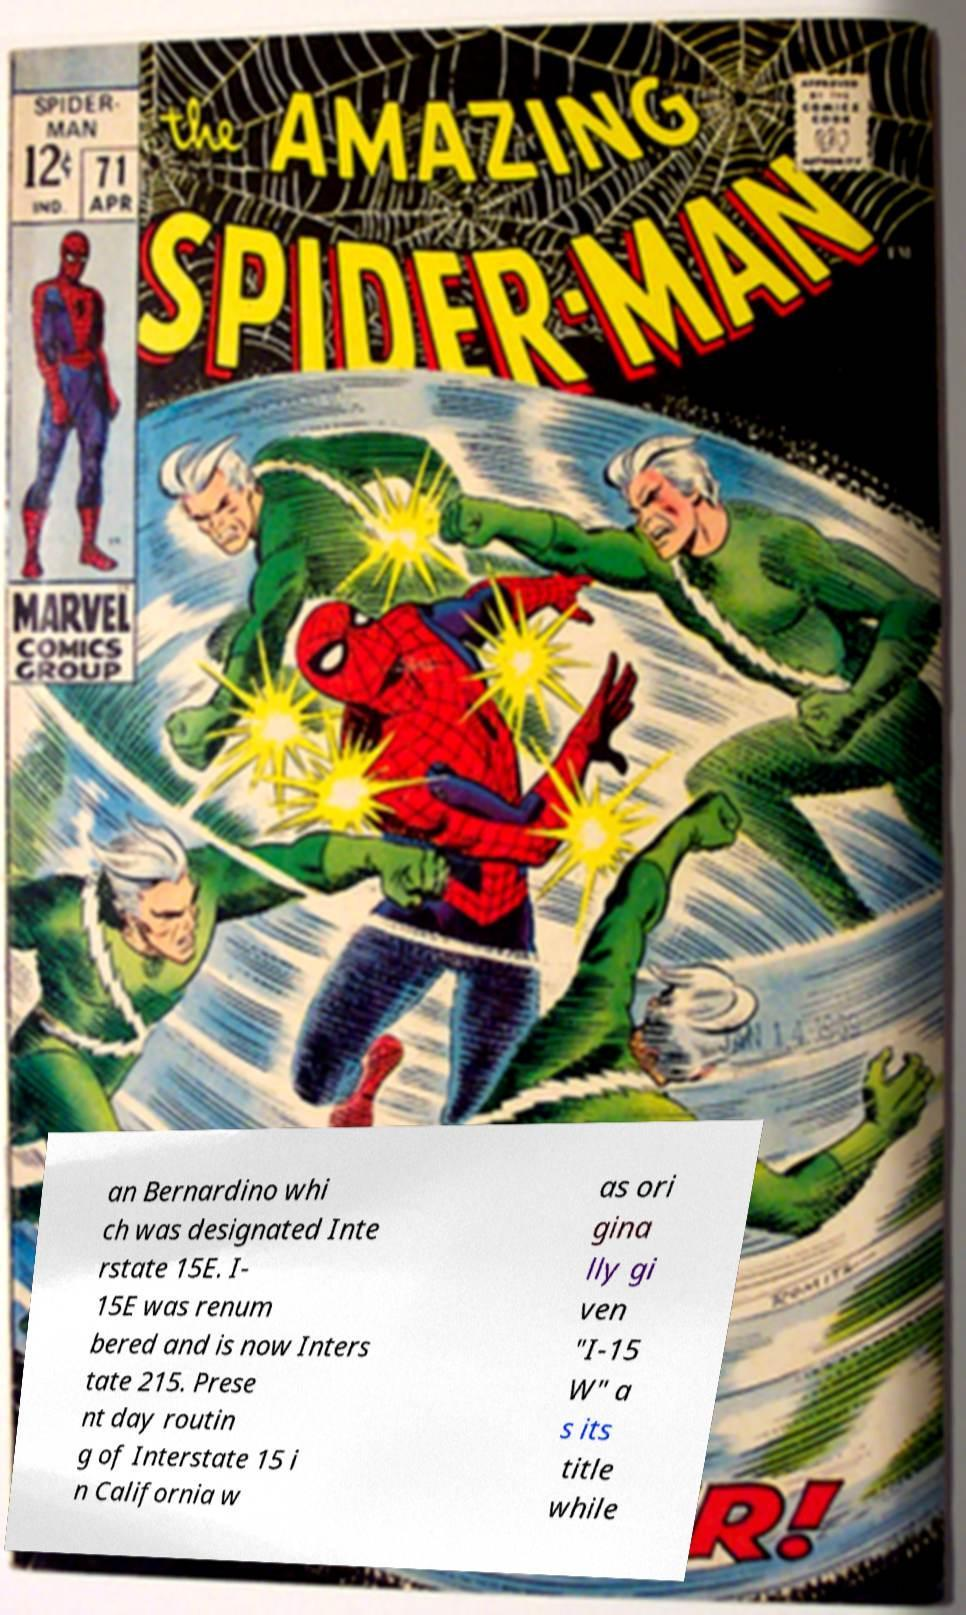Please read and relay the text visible in this image. What does it say? an Bernardino whi ch was designated Inte rstate 15E. I- 15E was renum bered and is now Inters tate 215. Prese nt day routin g of Interstate 15 i n California w as ori gina lly gi ven "I-15 W" a s its title while 